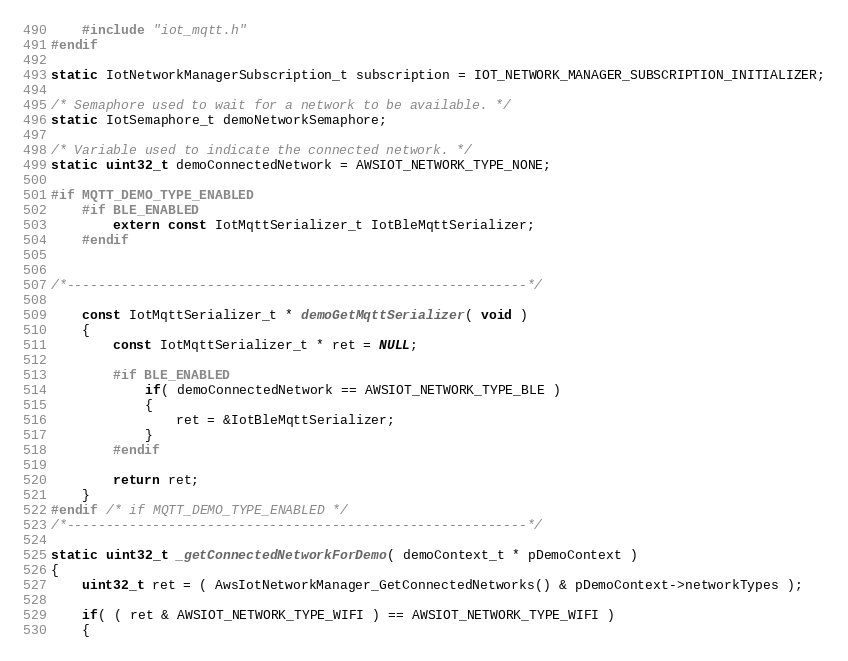Convert code to text. <code><loc_0><loc_0><loc_500><loc_500><_C_>    #include "iot_mqtt.h"
#endif

static IotNetworkManagerSubscription_t subscription = IOT_NETWORK_MANAGER_SUBSCRIPTION_INITIALIZER;

/* Semaphore used to wait for a network to be available. */
static IotSemaphore_t demoNetworkSemaphore;

/* Variable used to indicate the connected network. */
static uint32_t demoConnectedNetwork = AWSIOT_NETWORK_TYPE_NONE;

#if MQTT_DEMO_TYPE_ENABLED
    #if BLE_ENABLED
        extern const IotMqttSerializer_t IotBleMqttSerializer;
    #endif


/*-----------------------------------------------------------*/

    const IotMqttSerializer_t * demoGetMqttSerializer( void )
    {
        const IotMqttSerializer_t * ret = NULL;

        #if BLE_ENABLED
            if( demoConnectedNetwork == AWSIOT_NETWORK_TYPE_BLE )
            {
                ret = &IotBleMqttSerializer;
            }
        #endif

        return ret;
    }
#endif /* if MQTT_DEMO_TYPE_ENABLED */
/*-----------------------------------------------------------*/

static uint32_t _getConnectedNetworkForDemo( demoContext_t * pDemoContext )
{
    uint32_t ret = ( AwsIotNetworkManager_GetConnectedNetworks() & pDemoContext->networkTypes );

    if( ( ret & AWSIOT_NETWORK_TYPE_WIFI ) == AWSIOT_NETWORK_TYPE_WIFI )
    {</code> 